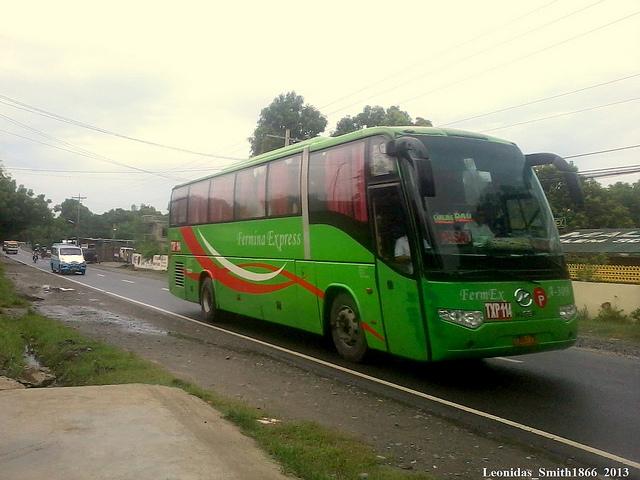Does the bus have passengers?
Keep it brief. Yes. Is there traffic?
Be succinct. Yes. Is the bus in motion?
Keep it brief. Yes. What color is the bus?
Be succinct. Green. Why is the bus parked along the side of the road?
Answer briefly. Bus stop. What does the side of the bus say?
Answer briefly. Fermina express. Is the bus parked?
Quick response, please. No. 